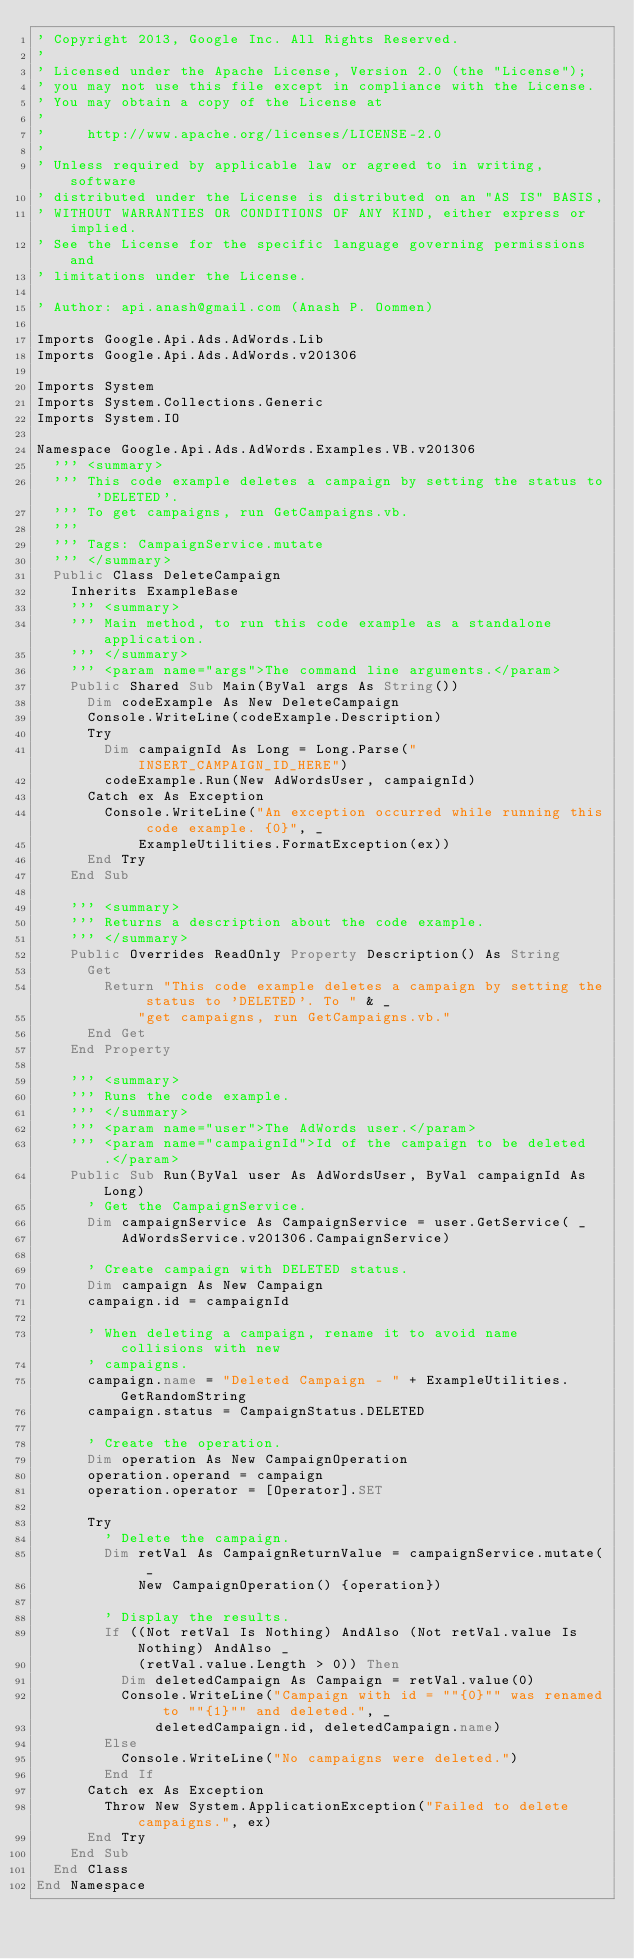Convert code to text. <code><loc_0><loc_0><loc_500><loc_500><_VisualBasic_>' Copyright 2013, Google Inc. All Rights Reserved.
'
' Licensed under the Apache License, Version 2.0 (the "License");
' you may not use this file except in compliance with the License.
' You may obtain a copy of the License at
'
'     http://www.apache.org/licenses/LICENSE-2.0
'
' Unless required by applicable law or agreed to in writing, software
' distributed under the License is distributed on an "AS IS" BASIS,
' WITHOUT WARRANTIES OR CONDITIONS OF ANY KIND, either express or implied.
' See the License for the specific language governing permissions and
' limitations under the License.

' Author: api.anash@gmail.com (Anash P. Oommen)

Imports Google.Api.Ads.AdWords.Lib
Imports Google.Api.Ads.AdWords.v201306

Imports System
Imports System.Collections.Generic
Imports System.IO

Namespace Google.Api.Ads.AdWords.Examples.VB.v201306
  ''' <summary>
  ''' This code example deletes a campaign by setting the status to 'DELETED'.
  ''' To get campaigns, run GetCampaigns.vb.
  '''
  ''' Tags: CampaignService.mutate
  ''' </summary>
  Public Class DeleteCampaign
    Inherits ExampleBase
    ''' <summary>
    ''' Main method, to run this code example as a standalone application.
    ''' </summary>
    ''' <param name="args">The command line arguments.</param>
    Public Shared Sub Main(ByVal args As String())
      Dim codeExample As New DeleteCampaign
      Console.WriteLine(codeExample.Description)
      Try
        Dim campaignId As Long = Long.Parse("INSERT_CAMPAIGN_ID_HERE")
        codeExample.Run(New AdWordsUser, campaignId)
      Catch ex As Exception
        Console.WriteLine("An exception occurred while running this code example. {0}", _
            ExampleUtilities.FormatException(ex))
      End Try
    End Sub

    ''' <summary>
    ''' Returns a description about the code example.
    ''' </summary>
    Public Overrides ReadOnly Property Description() As String
      Get
        Return "This code example deletes a campaign by setting the status to 'DELETED'. To " & _
            "get campaigns, run GetCampaigns.vb."
      End Get
    End Property

    ''' <summary>
    ''' Runs the code example.
    ''' </summary>
    ''' <param name="user">The AdWords user.</param>
    ''' <param name="campaignId">Id of the campaign to be deleted.</param>
    Public Sub Run(ByVal user As AdWordsUser, ByVal campaignId As Long)
      ' Get the CampaignService.
      Dim campaignService As CampaignService = user.GetService( _
          AdWordsService.v201306.CampaignService)

      ' Create campaign with DELETED status.
      Dim campaign As New Campaign
      campaign.id = campaignId

      ' When deleting a campaign, rename it to avoid name collisions with new
      ' campaigns.
      campaign.name = "Deleted Campaign - " + ExampleUtilities.GetRandomString
      campaign.status = CampaignStatus.DELETED

      ' Create the operation.
      Dim operation As New CampaignOperation
      operation.operand = campaign
      operation.operator = [Operator].SET

      Try
        ' Delete the campaign.
        Dim retVal As CampaignReturnValue = campaignService.mutate( _
            New CampaignOperation() {operation})

        ' Display the results.
        If ((Not retVal Is Nothing) AndAlso (Not retVal.value Is Nothing) AndAlso _
            (retVal.value.Length > 0)) Then
          Dim deletedCampaign As Campaign = retVal.value(0)
          Console.WriteLine("Campaign with id = ""{0}"" was renamed to ""{1}"" and deleted.", _
              deletedCampaign.id, deletedCampaign.name)
        Else
          Console.WriteLine("No campaigns were deleted.")
        End If
      Catch ex As Exception
        Throw New System.ApplicationException("Failed to delete campaigns.", ex)
      End Try
    End Sub
  End Class
End Namespace
</code> 